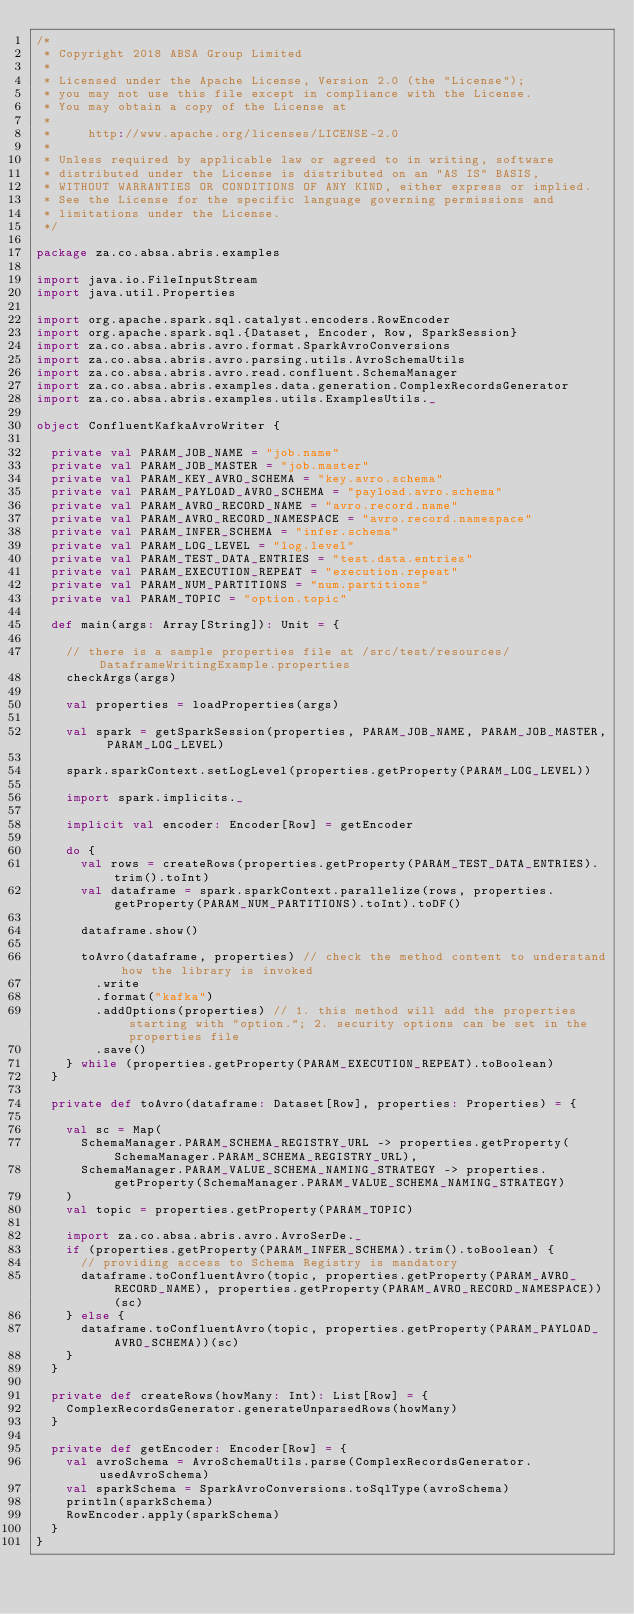<code> <loc_0><loc_0><loc_500><loc_500><_Scala_>/*
 * Copyright 2018 ABSA Group Limited
 *
 * Licensed under the Apache License, Version 2.0 (the "License");
 * you may not use this file except in compliance with the License.
 * You may obtain a copy of the License at
 *
 *     http://www.apache.org/licenses/LICENSE-2.0
 *
 * Unless required by applicable law or agreed to in writing, software
 * distributed under the License is distributed on an "AS IS" BASIS,
 * WITHOUT WARRANTIES OR CONDITIONS OF ANY KIND, either express or implied.
 * See the License for the specific language governing permissions and
 * limitations under the License.
 */

package za.co.absa.abris.examples

import java.io.FileInputStream
import java.util.Properties

import org.apache.spark.sql.catalyst.encoders.RowEncoder
import org.apache.spark.sql.{Dataset, Encoder, Row, SparkSession}
import za.co.absa.abris.avro.format.SparkAvroConversions
import za.co.absa.abris.avro.parsing.utils.AvroSchemaUtils
import za.co.absa.abris.avro.read.confluent.SchemaManager
import za.co.absa.abris.examples.data.generation.ComplexRecordsGenerator
import za.co.absa.abris.examples.utils.ExamplesUtils._

object ConfluentKafkaAvroWriter {

  private val PARAM_JOB_NAME = "job.name"
  private val PARAM_JOB_MASTER = "job.master"
  private val PARAM_KEY_AVRO_SCHEMA = "key.avro.schema"
  private val PARAM_PAYLOAD_AVRO_SCHEMA = "payload.avro.schema"
  private val PARAM_AVRO_RECORD_NAME = "avro.record.name"
  private val PARAM_AVRO_RECORD_NAMESPACE = "avro.record.namespace"
  private val PARAM_INFER_SCHEMA = "infer.schema"
  private val PARAM_LOG_LEVEL = "log.level"
  private val PARAM_TEST_DATA_ENTRIES = "test.data.entries"
  private val PARAM_EXECUTION_REPEAT = "execution.repeat"
  private val PARAM_NUM_PARTITIONS = "num.partitions"
  private val PARAM_TOPIC = "option.topic"

  def main(args: Array[String]): Unit = {

    // there is a sample properties file at /src/test/resources/DataframeWritingExample.properties
    checkArgs(args)

    val properties = loadProperties(args)

    val spark = getSparkSession(properties, PARAM_JOB_NAME, PARAM_JOB_MASTER, PARAM_LOG_LEVEL)

    spark.sparkContext.setLogLevel(properties.getProperty(PARAM_LOG_LEVEL))

    import spark.implicits._

    implicit val encoder: Encoder[Row] = getEncoder

    do {
      val rows = createRows(properties.getProperty(PARAM_TEST_DATA_ENTRIES).trim().toInt)
      val dataframe = spark.sparkContext.parallelize(rows, properties.getProperty(PARAM_NUM_PARTITIONS).toInt).toDF()

      dataframe.show()

      toAvro(dataframe, properties) // check the method content to understand how the library is invoked
        .write
        .format("kafka")
        .addOptions(properties) // 1. this method will add the properties starting with "option."; 2. security options can be set in the properties file
        .save()
    } while (properties.getProperty(PARAM_EXECUTION_REPEAT).toBoolean)
  }

  private def toAvro(dataframe: Dataset[Row], properties: Properties) = {

    val sc = Map(
      SchemaManager.PARAM_SCHEMA_REGISTRY_URL -> properties.getProperty(SchemaManager.PARAM_SCHEMA_REGISTRY_URL),
      SchemaManager.PARAM_VALUE_SCHEMA_NAMING_STRATEGY -> properties.getProperty(SchemaManager.PARAM_VALUE_SCHEMA_NAMING_STRATEGY)
    )
    val topic = properties.getProperty(PARAM_TOPIC)

    import za.co.absa.abris.avro.AvroSerDe._
    if (properties.getProperty(PARAM_INFER_SCHEMA).trim().toBoolean) {
      // providing access to Schema Registry is mandatory
      dataframe.toConfluentAvro(topic, properties.getProperty(PARAM_AVRO_RECORD_NAME), properties.getProperty(PARAM_AVRO_RECORD_NAMESPACE))(sc)
    } else {
      dataframe.toConfluentAvro(topic, properties.getProperty(PARAM_PAYLOAD_AVRO_SCHEMA))(sc)
    }
  }

  private def createRows(howMany: Int): List[Row] = {
    ComplexRecordsGenerator.generateUnparsedRows(howMany)
  }

  private def getEncoder: Encoder[Row] = {
    val avroSchema = AvroSchemaUtils.parse(ComplexRecordsGenerator.usedAvroSchema)
    val sparkSchema = SparkAvroConversions.toSqlType(avroSchema)
    println(sparkSchema)
    RowEncoder.apply(sparkSchema)
  }
}</code> 